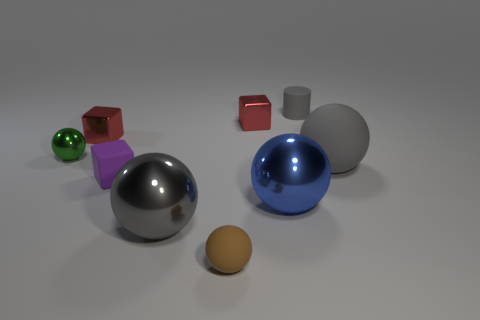Subtract all brown spheres. How many spheres are left? 4 Subtract all red cubes. How many cubes are left? 1 Subtract all green cubes. How many yellow spheres are left? 0 Subtract all rubber cubes. Subtract all tiny green spheres. How many objects are left? 7 Add 7 blocks. How many blocks are left? 10 Add 7 large gray things. How many large gray things exist? 9 Subtract 0 green cylinders. How many objects are left? 9 Subtract all spheres. How many objects are left? 4 Subtract 2 blocks. How many blocks are left? 1 Subtract all cyan cylinders. Subtract all green cubes. How many cylinders are left? 1 